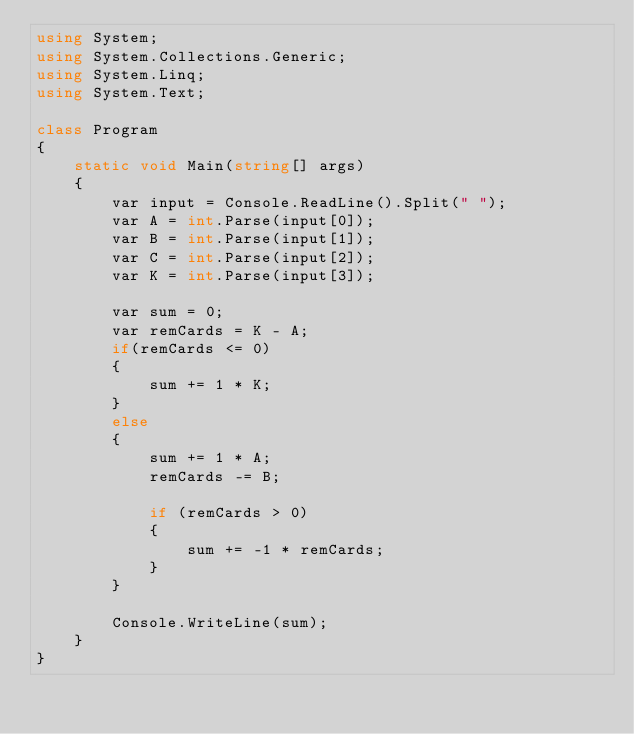Convert code to text. <code><loc_0><loc_0><loc_500><loc_500><_C#_>using System;
using System.Collections.Generic;
using System.Linq;
using System.Text;

class Program
{
    static void Main(string[] args)
    {
        var input = Console.ReadLine().Split(" ");
        var A = int.Parse(input[0]);
        var B = int.Parse(input[1]);
        var C = int.Parse(input[2]);
        var K = int.Parse(input[3]);

        var sum = 0;
        var remCards = K - A;
        if(remCards <= 0)
        {
            sum += 1 * K;
        }
        else
        {
            sum += 1 * A;
            remCards -= B;

            if (remCards > 0)
            {
                sum += -1 * remCards;
            }
        }

        Console.WriteLine(sum);
    }
}
</code> 